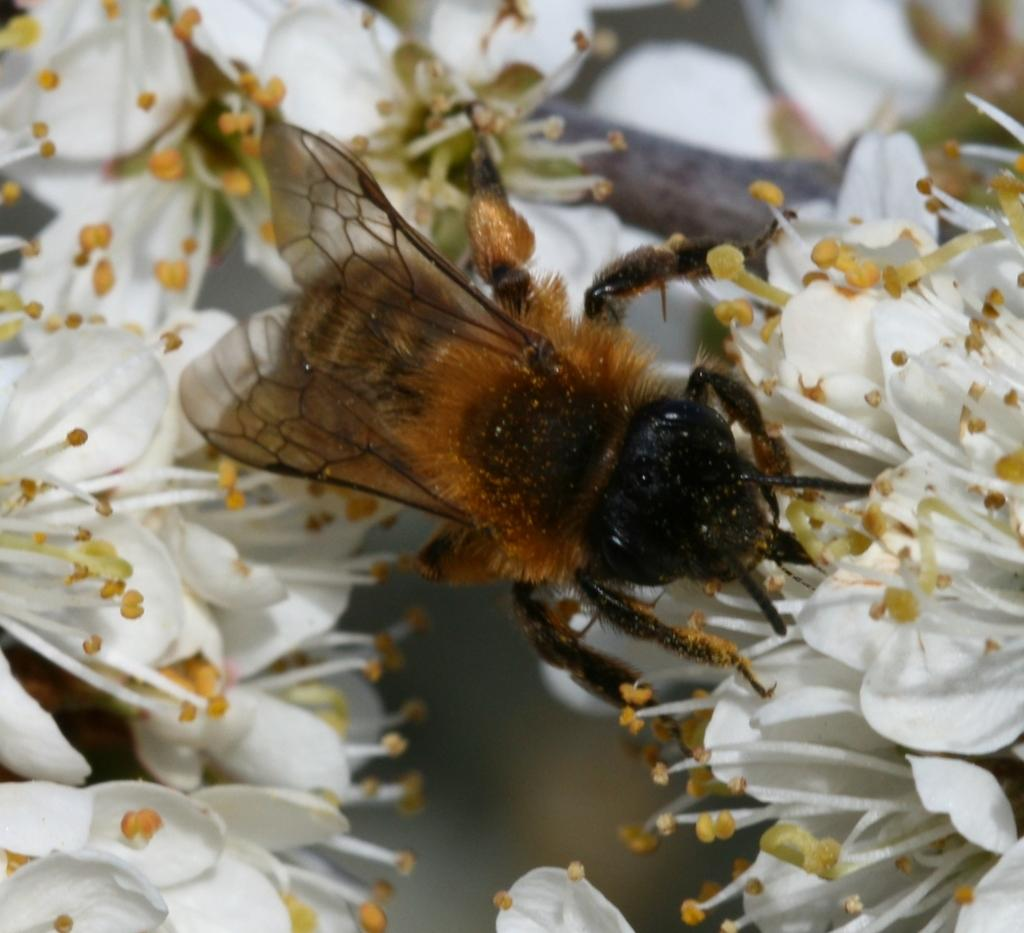What type of living organisms can be seen in the image? Insects and white flowers are visible in the image. Can you describe the insects in the image? Unfortunately, the facts provided do not give specific details about the insects. What color are the flowers in the image? The flowers in the image are white. How many beads are attached to the scarecrow in the image? There is no scarecrow or beads present in the image. What type of bee can be seen buzzing around the flowers in the image? There is no bee present in the image; only insects and white flowers are visible. 